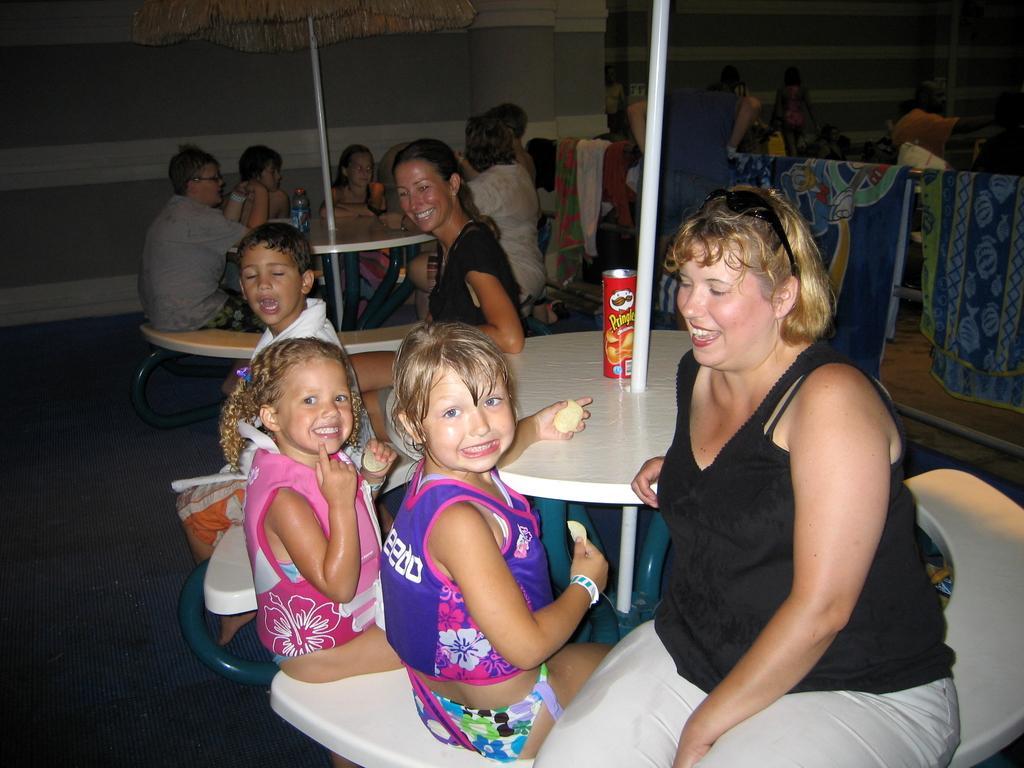In one or two sentences, can you explain what this image depicts? This picture describe about the restaurant in which group of people are sitting in that, in front side there is a lady sitting, wearing a black T-shirt and grey color pant beside there are two small girl are sitting which are eating the chips and wearing swimming costume. Another small girl and boy wearing a white shirt and sitting on the bench. and in front of the girl there is chip can and behind there is another lady. who is watching and laughing on them, behind them there are another group of people who occupy the another table and behind them there is grey color wall, in write side there are two bed sheet on pipe. And behind them a person wearing white color T- shirt and group of people sitting on the table. 